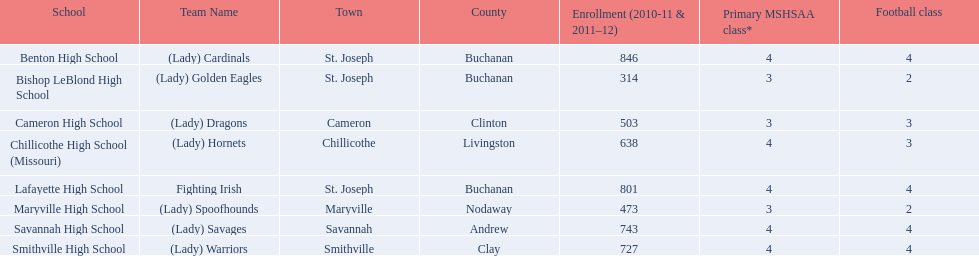In the 2010-2011 and 2011-2012 academic years, how many schools had a minimum enrollment of 500 students? 6. 